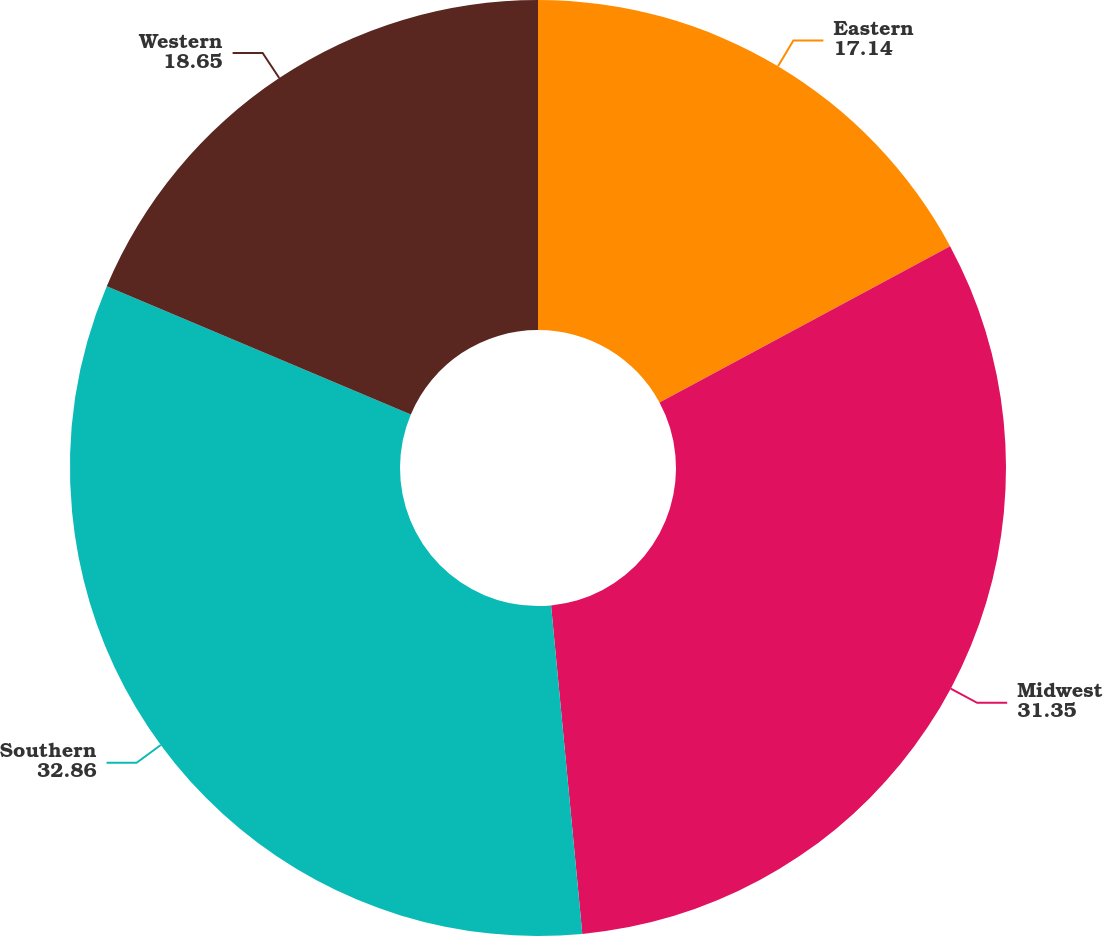Convert chart to OTSL. <chart><loc_0><loc_0><loc_500><loc_500><pie_chart><fcel>Eastern<fcel>Midwest<fcel>Southern<fcel>Western<nl><fcel>17.14%<fcel>31.35%<fcel>32.86%<fcel>18.65%<nl></chart> 